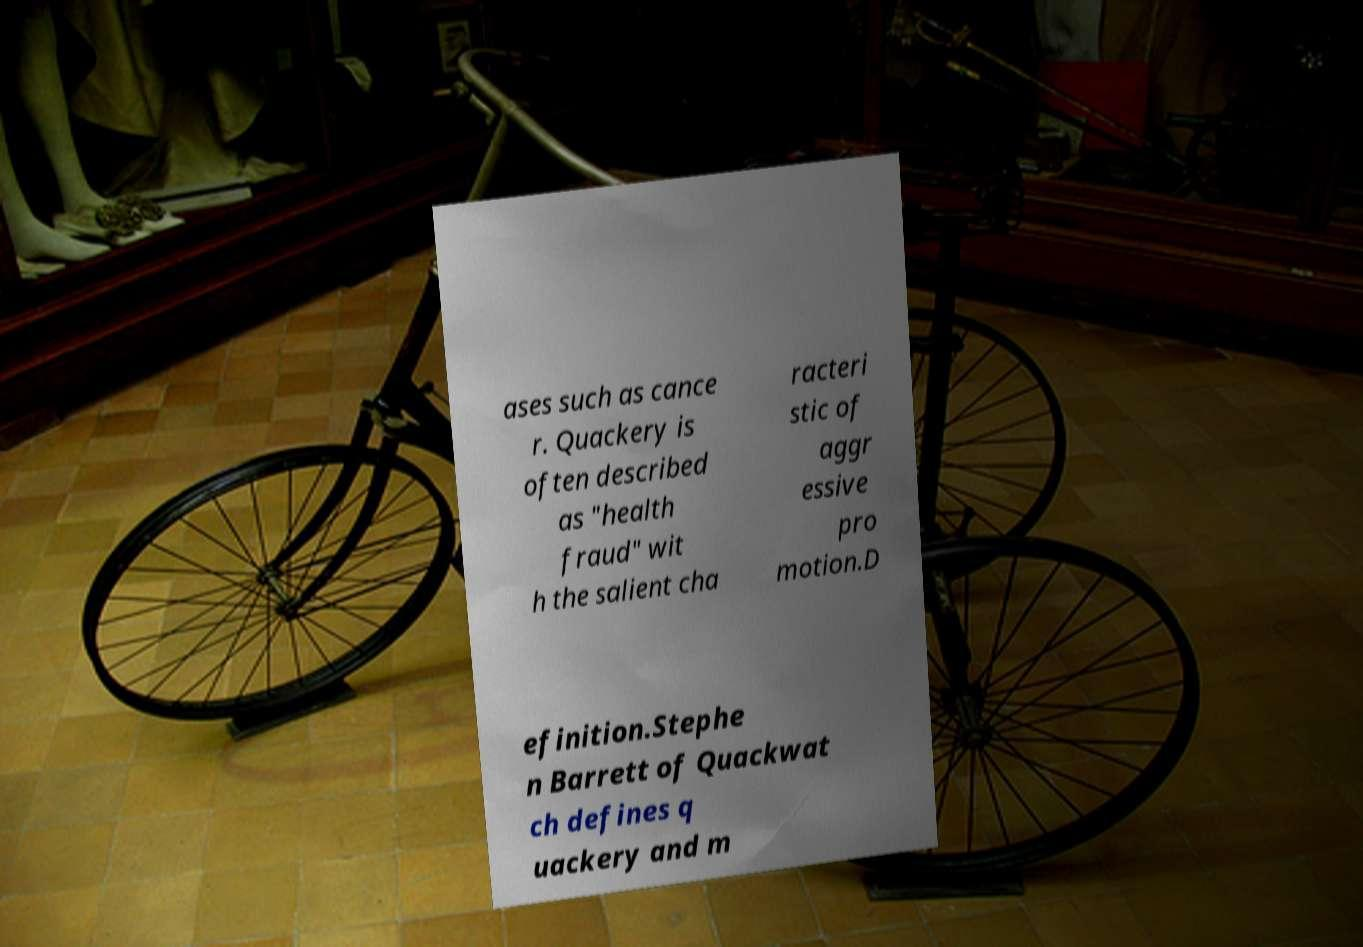What messages or text are displayed in this image? I need them in a readable, typed format. ases such as cance r. Quackery is often described as "health fraud" wit h the salient cha racteri stic of aggr essive pro motion.D efinition.Stephe n Barrett of Quackwat ch defines q uackery and m 